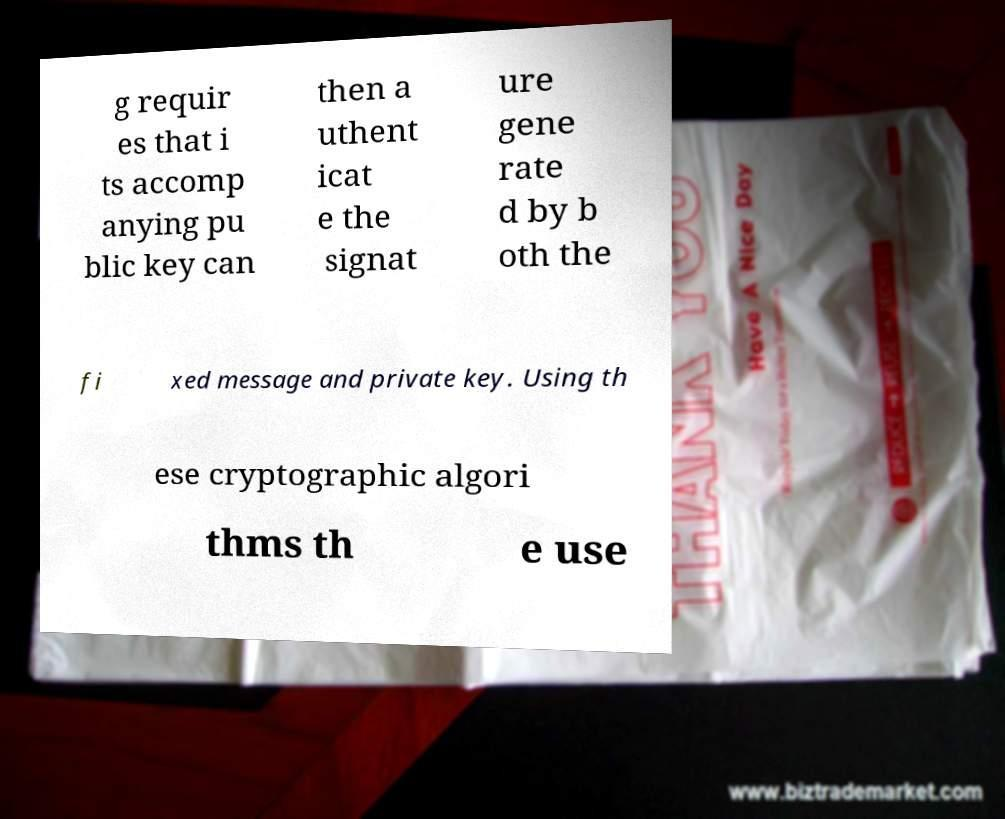What messages or text are displayed in this image? I need them in a readable, typed format. g requir es that i ts accomp anying pu blic key can then a uthent icat e the signat ure gene rate d by b oth the fi xed message and private key. Using th ese cryptographic algori thms th e use 